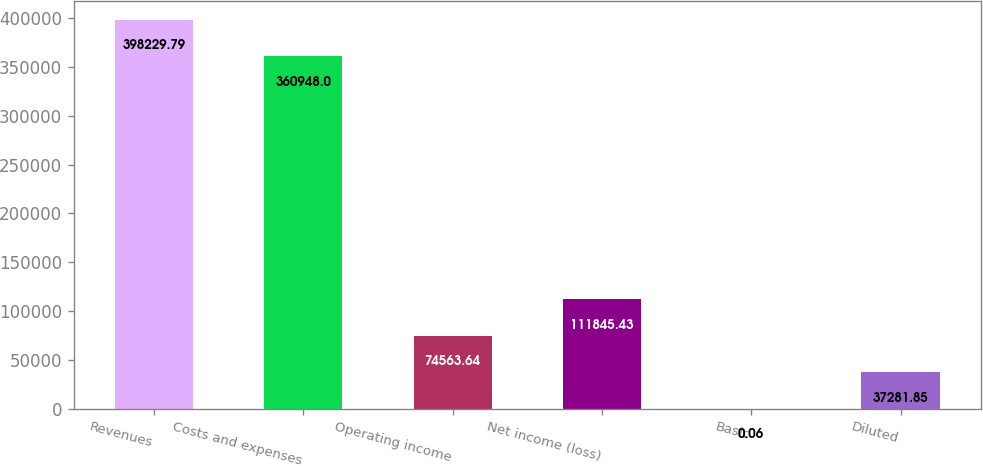Convert chart to OTSL. <chart><loc_0><loc_0><loc_500><loc_500><bar_chart><fcel>Revenues<fcel>Costs and expenses<fcel>Operating income<fcel>Net income (loss)<fcel>Basic<fcel>Diluted<nl><fcel>398230<fcel>360948<fcel>74563.6<fcel>111845<fcel>0.06<fcel>37281.8<nl></chart> 